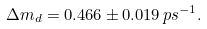<formula> <loc_0><loc_0><loc_500><loc_500>\Delta m _ { d } = 0 . 4 6 6 \pm 0 . 0 1 9 \, p s ^ { - 1 } .</formula> 